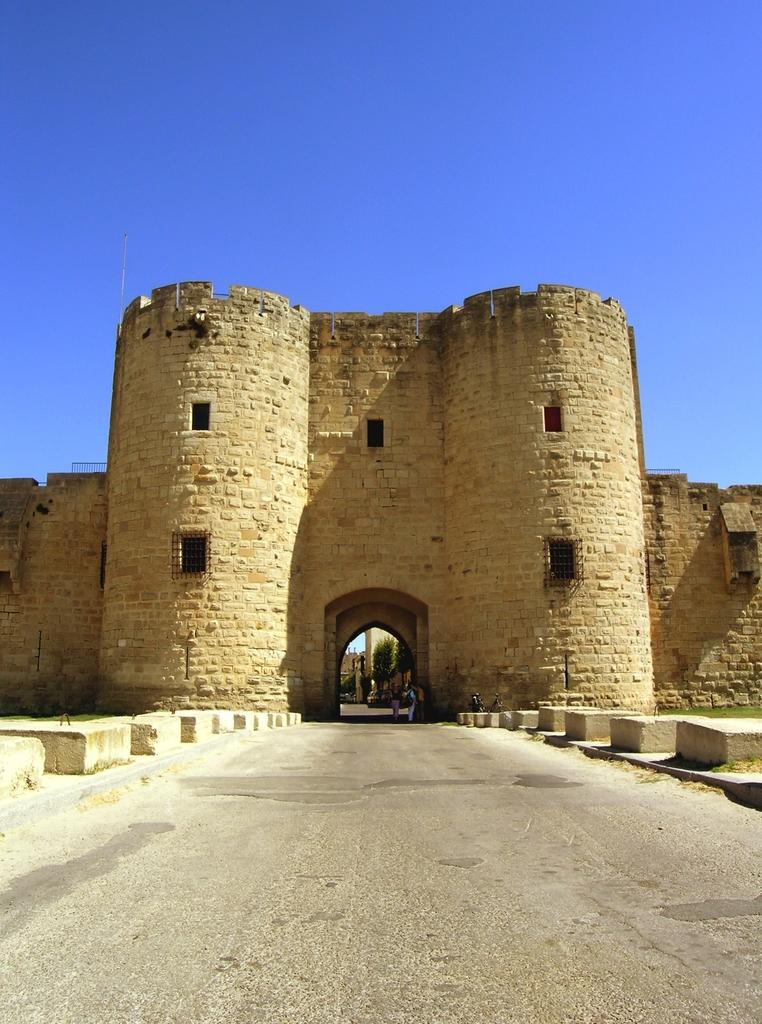What is the main subject of the image? The main subject of the image is the entrance of a fort. What color is the wall near the entrance? The wall near the entrance is cream-colored. What is in front of the entrance? There is a road in front of the entrance. What can be seen in the background of the image? The sky is visible in the background of the image. What type of glue is being used by the judge in the image? There is no judge or glue present in the image; it features the entrance of a fort with a cream-colored wall and a road in front of it. 